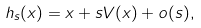Convert formula to latex. <formula><loc_0><loc_0><loc_500><loc_500>h _ { s } ( x ) = x + s V ( x ) + o ( s ) ,</formula> 